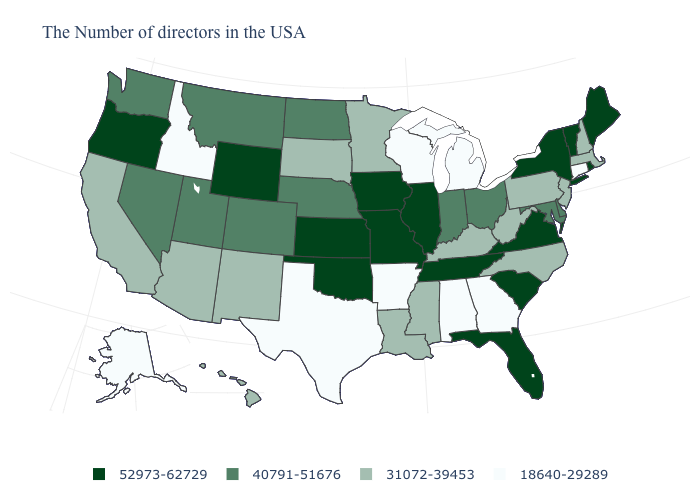Does New Hampshire have the same value as New Jersey?
Be succinct. Yes. Does the first symbol in the legend represent the smallest category?
Quick response, please. No. Name the states that have a value in the range 40791-51676?
Answer briefly. Delaware, Maryland, Ohio, Indiana, Nebraska, North Dakota, Colorado, Utah, Montana, Nevada, Washington. Name the states that have a value in the range 31072-39453?
Quick response, please. Massachusetts, New Hampshire, New Jersey, Pennsylvania, North Carolina, West Virginia, Kentucky, Mississippi, Louisiana, Minnesota, South Dakota, New Mexico, Arizona, California, Hawaii. Does Illinois have the highest value in the USA?
Write a very short answer. Yes. Name the states that have a value in the range 52973-62729?
Concise answer only. Maine, Rhode Island, Vermont, New York, Virginia, South Carolina, Florida, Tennessee, Illinois, Missouri, Iowa, Kansas, Oklahoma, Wyoming, Oregon. Does Michigan have the lowest value in the USA?
Be succinct. Yes. Which states hav the highest value in the MidWest?
Quick response, please. Illinois, Missouri, Iowa, Kansas. What is the highest value in states that border Nebraska?
Keep it brief. 52973-62729. Name the states that have a value in the range 18640-29289?
Write a very short answer. Connecticut, Georgia, Michigan, Alabama, Wisconsin, Arkansas, Texas, Idaho, Alaska. Does the first symbol in the legend represent the smallest category?
Answer briefly. No. Name the states that have a value in the range 40791-51676?
Concise answer only. Delaware, Maryland, Ohio, Indiana, Nebraska, North Dakota, Colorado, Utah, Montana, Nevada, Washington. What is the highest value in states that border Alabama?
Answer briefly. 52973-62729. What is the lowest value in the West?
Quick response, please. 18640-29289. What is the highest value in the MidWest ?
Write a very short answer. 52973-62729. 